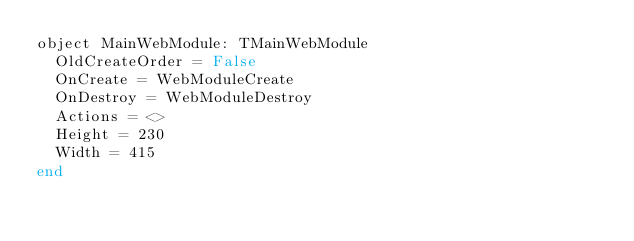Convert code to text. <code><loc_0><loc_0><loc_500><loc_500><_Pascal_>object MainWebModule: TMainWebModule
  OldCreateOrder = False
  OnCreate = WebModuleCreate
  OnDestroy = WebModuleDestroy
  Actions = <>
  Height = 230
  Width = 415
end
</code> 